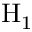Convert formula to latex. <formula><loc_0><loc_0><loc_500><loc_500>H _ { 1 }</formula> 